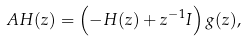Convert formula to latex. <formula><loc_0><loc_0><loc_500><loc_500>A H ( z ) = \left ( - H ( z ) + z ^ { - 1 } I \right ) g ( z ) ,</formula> 